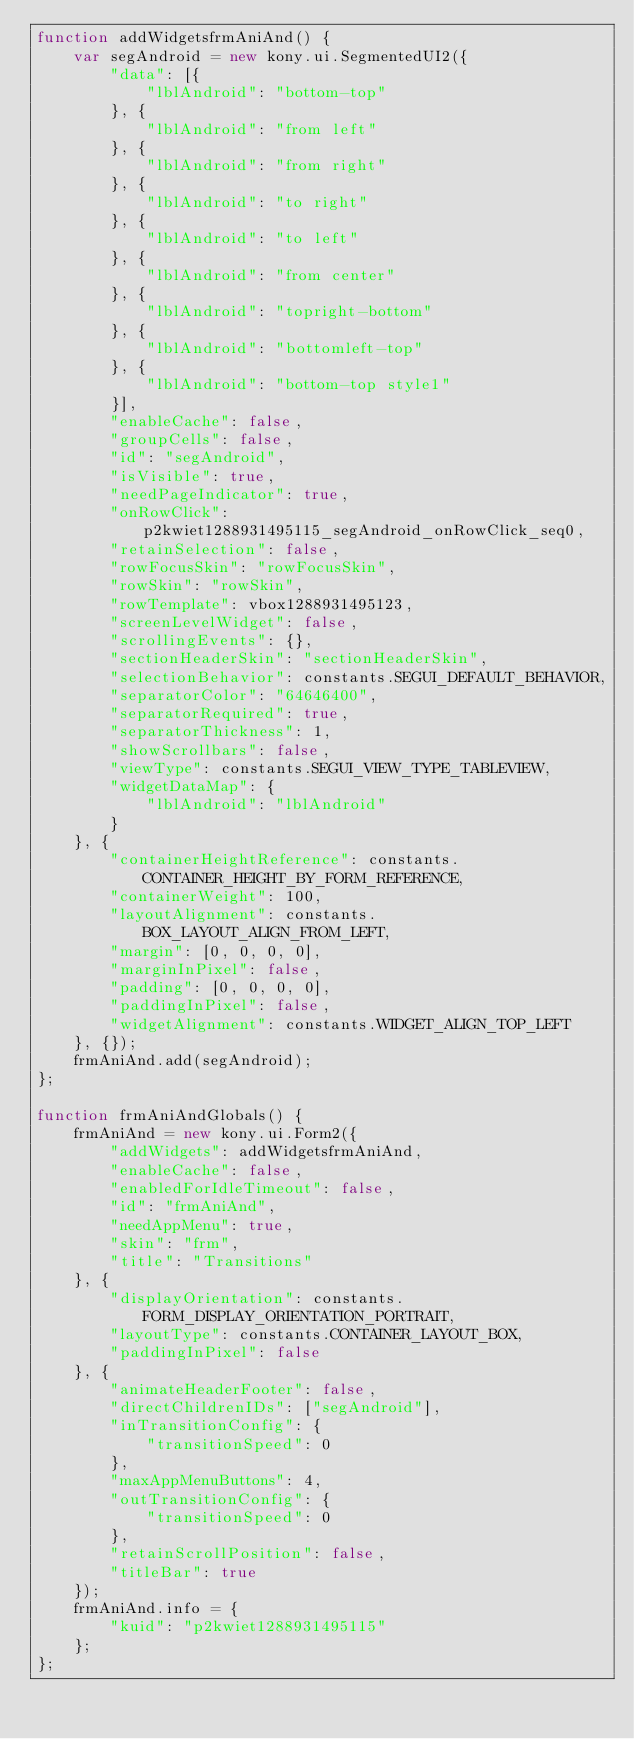Convert code to text. <code><loc_0><loc_0><loc_500><loc_500><_JavaScript_>function addWidgetsfrmAniAnd() {
    var segAndroid = new kony.ui.SegmentedUI2({
        "data": [{
            "lblAndroid": "bottom-top"
        }, {
            "lblAndroid": "from left"
        }, {
            "lblAndroid": "from right"
        }, {
            "lblAndroid": "to right"
        }, {
            "lblAndroid": "to left"
        }, {
            "lblAndroid": "from center"
        }, {
            "lblAndroid": "topright-bottom"
        }, {
            "lblAndroid": "bottomleft-top"
        }, {
            "lblAndroid": "bottom-top style1"
        }],
        "enableCache": false,
        "groupCells": false,
        "id": "segAndroid",
        "isVisible": true,
        "needPageIndicator": true,
        "onRowClick": p2kwiet1288931495115_segAndroid_onRowClick_seq0,
        "retainSelection": false,
        "rowFocusSkin": "rowFocusSkin",
        "rowSkin": "rowSkin",
        "rowTemplate": vbox1288931495123,
        "screenLevelWidget": false,
        "scrollingEvents": {},
        "sectionHeaderSkin": "sectionHeaderSkin",
        "selectionBehavior": constants.SEGUI_DEFAULT_BEHAVIOR,
        "separatorColor": "64646400",
        "separatorRequired": true,
        "separatorThickness": 1,
        "showScrollbars": false,
        "viewType": constants.SEGUI_VIEW_TYPE_TABLEVIEW,
        "widgetDataMap": {
            "lblAndroid": "lblAndroid"
        }
    }, {
        "containerHeightReference": constants.CONTAINER_HEIGHT_BY_FORM_REFERENCE,
        "containerWeight": 100,
        "layoutAlignment": constants.BOX_LAYOUT_ALIGN_FROM_LEFT,
        "margin": [0, 0, 0, 0],
        "marginInPixel": false,
        "padding": [0, 0, 0, 0],
        "paddingInPixel": false,
        "widgetAlignment": constants.WIDGET_ALIGN_TOP_LEFT
    }, {});
    frmAniAnd.add(segAndroid);
};

function frmAniAndGlobals() {
    frmAniAnd = new kony.ui.Form2({
        "addWidgets": addWidgetsfrmAniAnd,
        "enableCache": false,
        "enabledForIdleTimeout": false,
        "id": "frmAniAnd",
        "needAppMenu": true,
        "skin": "frm",
        "title": "Transitions"
    }, {
        "displayOrientation": constants.FORM_DISPLAY_ORIENTATION_PORTRAIT,
        "layoutType": constants.CONTAINER_LAYOUT_BOX,
        "paddingInPixel": false
    }, {
        "animateHeaderFooter": false,
        "directChildrenIDs": ["segAndroid"],
        "inTransitionConfig": {
            "transitionSpeed": 0
        },
        "maxAppMenuButtons": 4,
        "outTransitionConfig": {
            "transitionSpeed": 0
        },
        "retainScrollPosition": false,
        "titleBar": true
    });
    frmAniAnd.info = {
        "kuid": "p2kwiet1288931495115"
    };
};</code> 